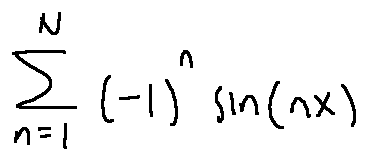Convert formula to latex. <formula><loc_0><loc_0><loc_500><loc_500>\sum \lim i t s _ { n = 1 } ^ { N } ( - 1 ) ^ { n } \sin ( n x )</formula> 